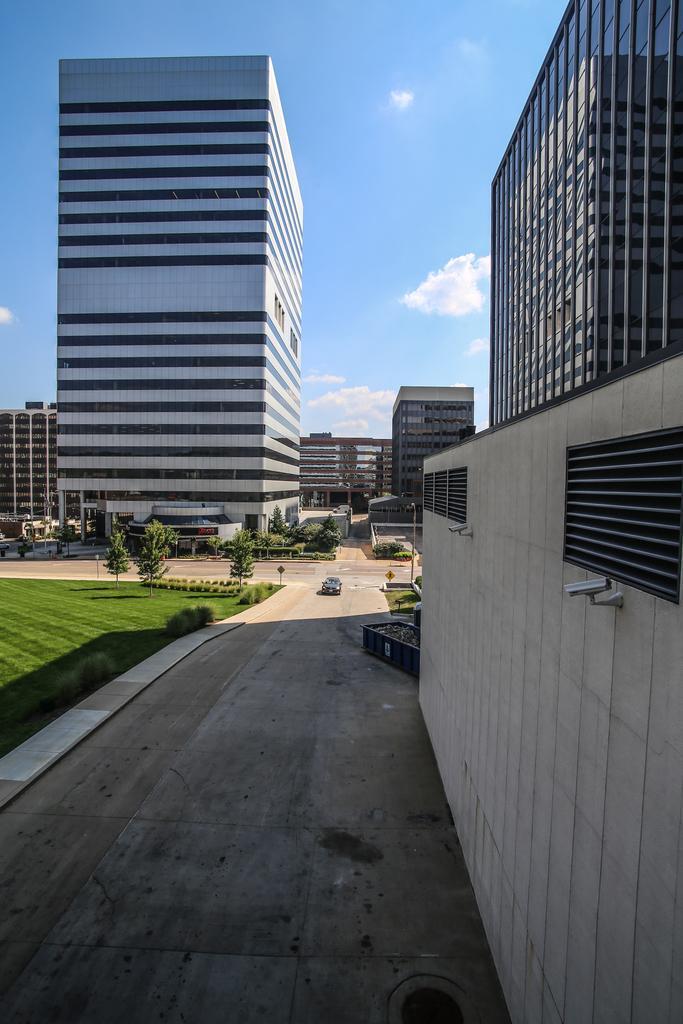Can you describe this image briefly? In this image I can see few buildings. I can see few trees. On the left side I can see some grass on the ground. I can see a vehicle on the road. On the right side I can see a wall. At the top I can see clouds in the sky. 